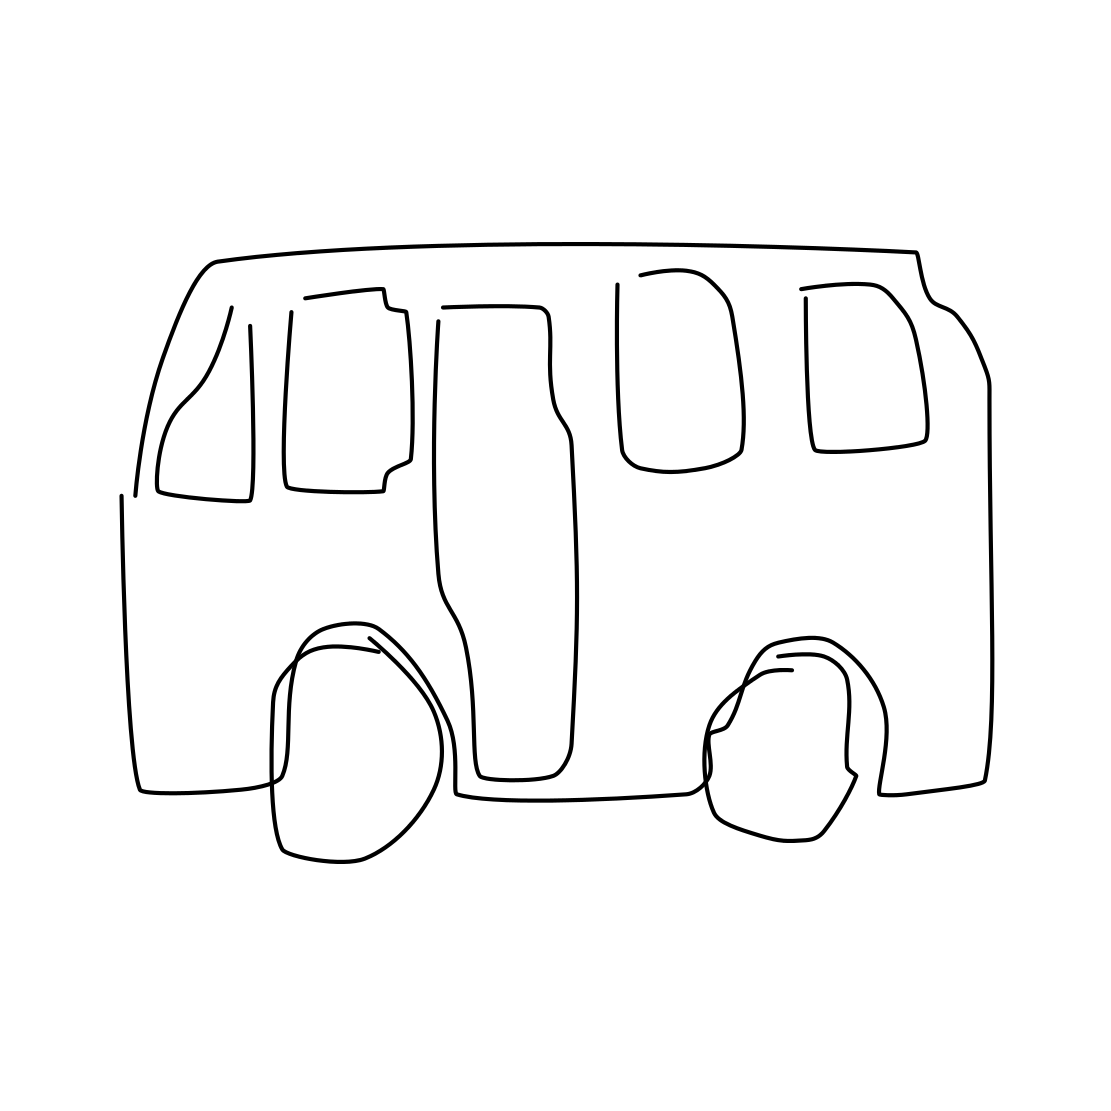How could this image be used? This image, with its simplicity and clean lines, is versatile. It could be used as an icon or a logo for a transportation service, a placeholder in a graphical representation of parking layouts, or as a part of an educational tool for children learning about transportation. 